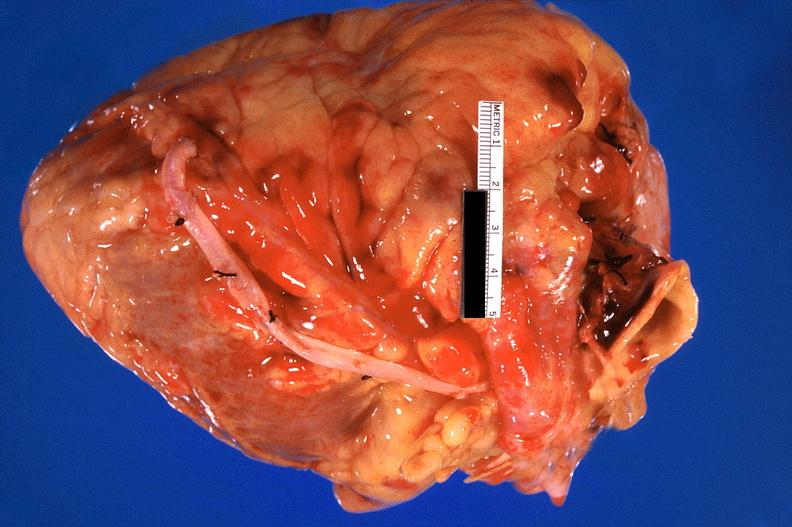s stillborn macerated present?
Answer the question using a single word or phrase. No 